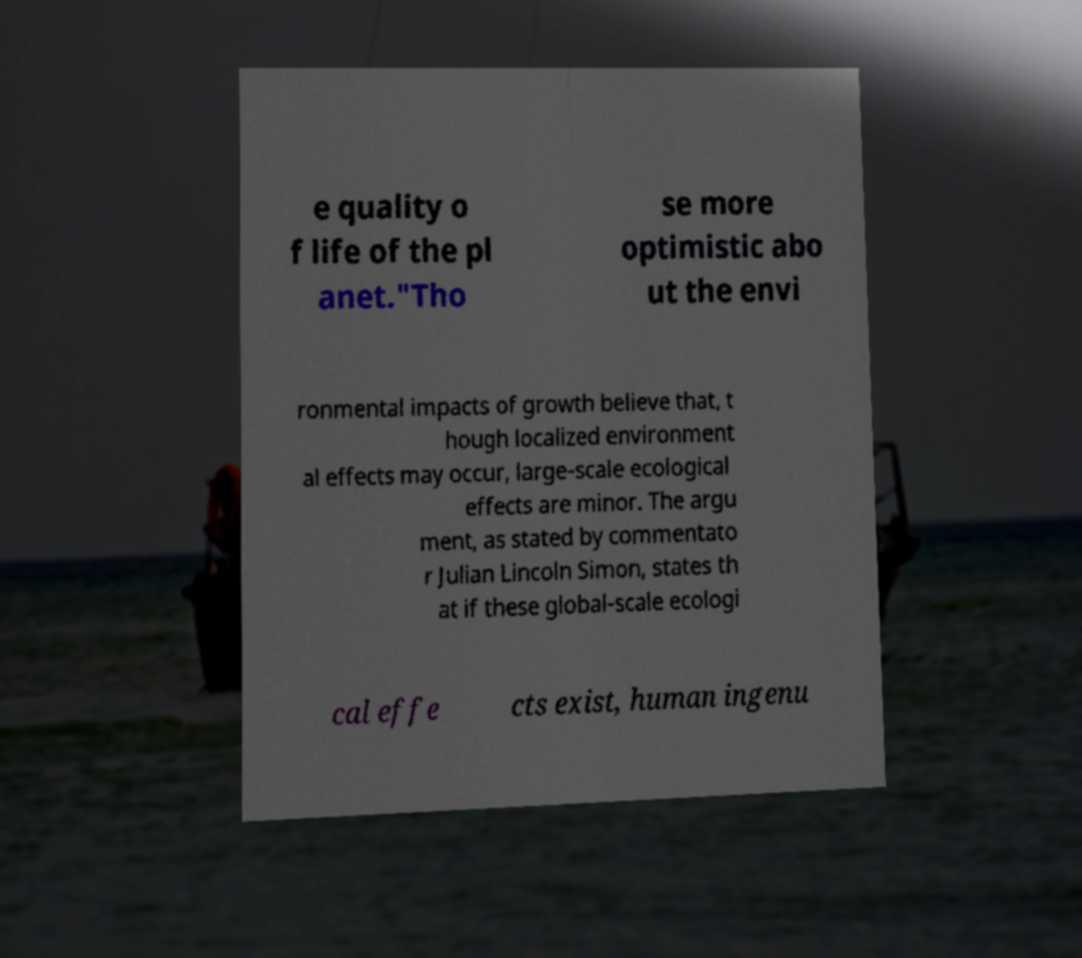Can you accurately transcribe the text from the provided image for me? e quality o f life of the pl anet."Tho se more optimistic abo ut the envi ronmental impacts of growth believe that, t hough localized environment al effects may occur, large-scale ecological effects are minor. The argu ment, as stated by commentato r Julian Lincoln Simon, states th at if these global-scale ecologi cal effe cts exist, human ingenu 